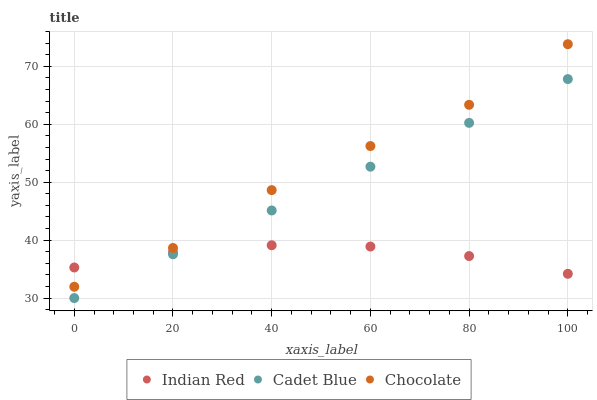Does Indian Red have the minimum area under the curve?
Answer yes or no. Yes. Does Chocolate have the maximum area under the curve?
Answer yes or no. Yes. Does Chocolate have the minimum area under the curve?
Answer yes or no. No. Does Indian Red have the maximum area under the curve?
Answer yes or no. No. Is Cadet Blue the smoothest?
Answer yes or no. Yes. Is Chocolate the roughest?
Answer yes or no. Yes. Is Indian Red the smoothest?
Answer yes or no. No. Is Indian Red the roughest?
Answer yes or no. No. Does Cadet Blue have the lowest value?
Answer yes or no. Yes. Does Chocolate have the lowest value?
Answer yes or no. No. Does Chocolate have the highest value?
Answer yes or no. Yes. Does Indian Red have the highest value?
Answer yes or no. No. Is Cadet Blue less than Chocolate?
Answer yes or no. Yes. Is Chocolate greater than Cadet Blue?
Answer yes or no. Yes. Does Indian Red intersect Chocolate?
Answer yes or no. Yes. Is Indian Red less than Chocolate?
Answer yes or no. No. Is Indian Red greater than Chocolate?
Answer yes or no. No. Does Cadet Blue intersect Chocolate?
Answer yes or no. No. 